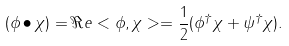Convert formula to latex. <formula><loc_0><loc_0><loc_500><loc_500>( \phi \bullet \chi ) = \Re e < \phi , \chi > = \frac { 1 } { 2 } ( \phi ^ { \dagger } \chi + \psi ^ { \dagger } \chi ) .</formula> 